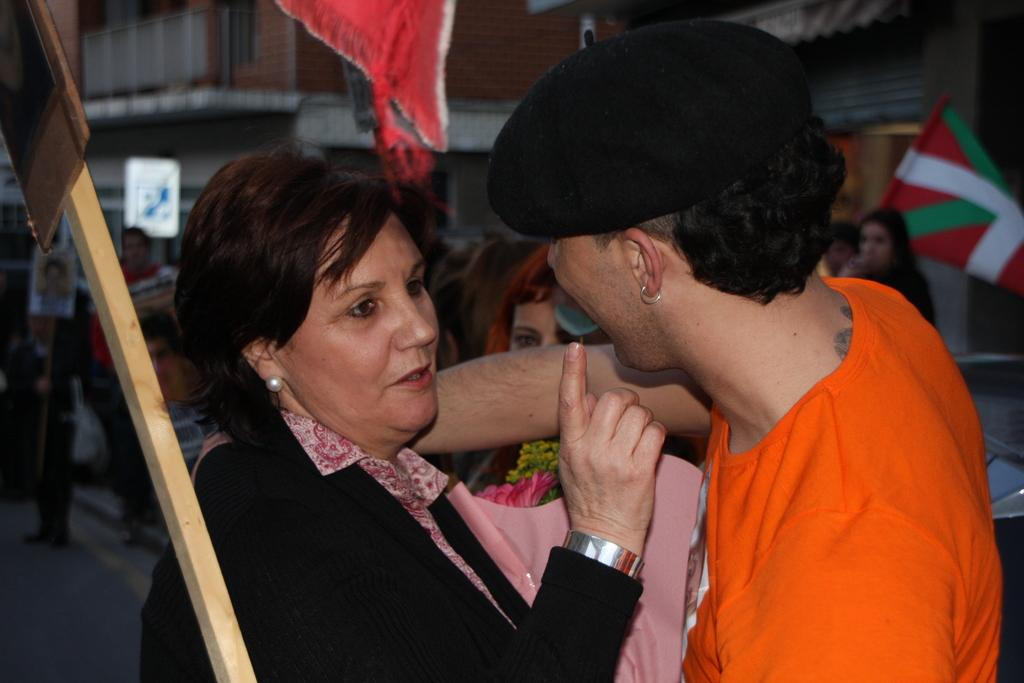How many people are present in the image? There are two people in the image, a woman and a man. What is the relationship between the man and the woman in the image? The man is standing close to the woman, which suggests they might be together or interacting in some way. What can be seen in the background of the image? There are people and at least one building in the background of the image. What type of chin can be seen on the woman in the image? There is no chin visible in the image, as the woman's face is not shown. Can you tell me how many planes are flying in the background of the image? There are no planes visible in the image; it only shows a man and a woman with a background of people and a building. 